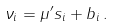Convert formula to latex. <formula><loc_0><loc_0><loc_500><loc_500>\nu _ { i } = \mu ^ { \prime } s _ { i } + b _ { i } \, .</formula> 